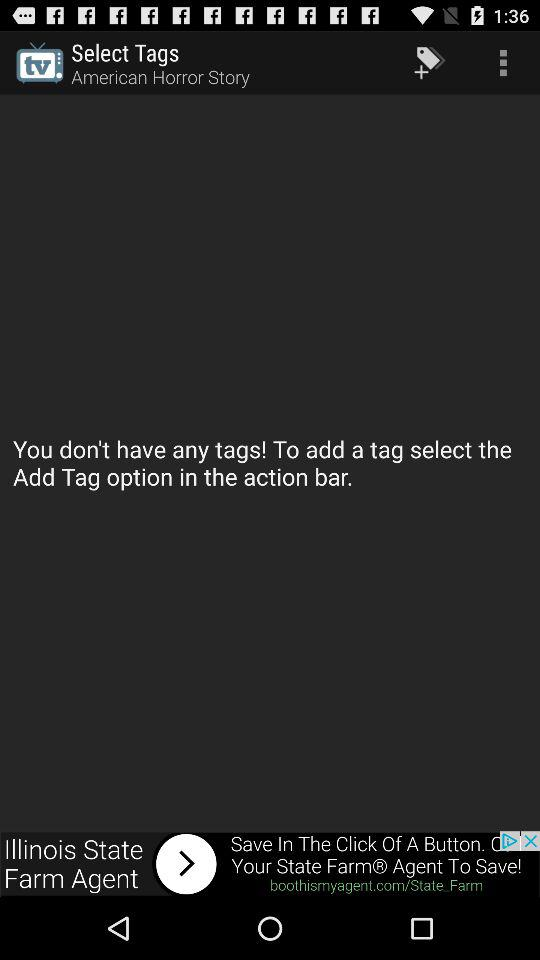Which option is selected in the select tags setting?
When the provided information is insufficient, respond with <no answer>. <no answer> 